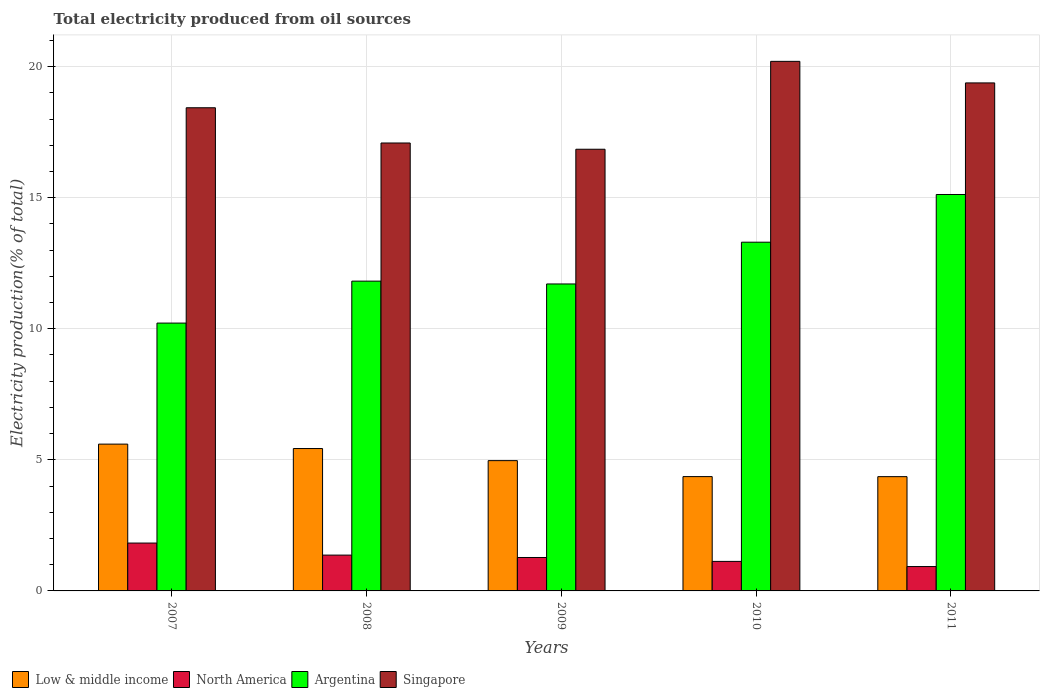How many groups of bars are there?
Make the answer very short. 5. Are the number of bars per tick equal to the number of legend labels?
Keep it short and to the point. Yes. How many bars are there on the 3rd tick from the left?
Give a very brief answer. 4. How many bars are there on the 5th tick from the right?
Give a very brief answer. 4. What is the label of the 1st group of bars from the left?
Give a very brief answer. 2007. In how many cases, is the number of bars for a given year not equal to the number of legend labels?
Your answer should be very brief. 0. What is the total electricity produced in North America in 2007?
Give a very brief answer. 1.83. Across all years, what is the maximum total electricity produced in Singapore?
Your answer should be compact. 20.2. Across all years, what is the minimum total electricity produced in Low & middle income?
Offer a very short reply. 4.36. In which year was the total electricity produced in Argentina maximum?
Offer a very short reply. 2011. What is the total total electricity produced in Argentina in the graph?
Provide a succinct answer. 62.17. What is the difference between the total electricity produced in North America in 2010 and that in 2011?
Ensure brevity in your answer.  0.2. What is the difference between the total electricity produced in North America in 2008 and the total electricity produced in Singapore in 2011?
Your answer should be very brief. -18.01. What is the average total electricity produced in North America per year?
Your response must be concise. 1.3. In the year 2007, what is the difference between the total electricity produced in Argentina and total electricity produced in Singapore?
Ensure brevity in your answer.  -8.21. What is the ratio of the total electricity produced in North America in 2007 to that in 2008?
Your response must be concise. 1.34. Is the total electricity produced in Low & middle income in 2008 less than that in 2011?
Make the answer very short. No. What is the difference between the highest and the second highest total electricity produced in Singapore?
Offer a terse response. 0.82. What is the difference between the highest and the lowest total electricity produced in Singapore?
Give a very brief answer. 3.35. In how many years, is the total electricity produced in Low & middle income greater than the average total electricity produced in Low & middle income taken over all years?
Your answer should be compact. 3. Is the sum of the total electricity produced in Argentina in 2007 and 2010 greater than the maximum total electricity produced in Low & middle income across all years?
Make the answer very short. Yes. What does the 4th bar from the left in 2011 represents?
Your answer should be compact. Singapore. Are the values on the major ticks of Y-axis written in scientific E-notation?
Offer a very short reply. No. Does the graph contain any zero values?
Your answer should be very brief. No. Does the graph contain grids?
Make the answer very short. Yes. Where does the legend appear in the graph?
Offer a terse response. Bottom left. How are the legend labels stacked?
Your answer should be very brief. Horizontal. What is the title of the graph?
Provide a short and direct response. Total electricity produced from oil sources. Does "Guyana" appear as one of the legend labels in the graph?
Provide a succinct answer. No. What is the label or title of the Y-axis?
Ensure brevity in your answer.  Electricity production(% of total). What is the Electricity production(% of total) of Low & middle income in 2007?
Make the answer very short. 5.6. What is the Electricity production(% of total) of North America in 2007?
Your response must be concise. 1.83. What is the Electricity production(% of total) in Argentina in 2007?
Your answer should be compact. 10.22. What is the Electricity production(% of total) in Singapore in 2007?
Provide a succinct answer. 18.43. What is the Electricity production(% of total) in Low & middle income in 2008?
Offer a terse response. 5.43. What is the Electricity production(% of total) of North America in 2008?
Provide a succinct answer. 1.37. What is the Electricity production(% of total) of Argentina in 2008?
Your answer should be compact. 11.82. What is the Electricity production(% of total) in Singapore in 2008?
Give a very brief answer. 17.09. What is the Electricity production(% of total) in Low & middle income in 2009?
Ensure brevity in your answer.  4.97. What is the Electricity production(% of total) in North America in 2009?
Give a very brief answer. 1.28. What is the Electricity production(% of total) of Argentina in 2009?
Make the answer very short. 11.71. What is the Electricity production(% of total) of Singapore in 2009?
Make the answer very short. 16.85. What is the Electricity production(% of total) in Low & middle income in 2010?
Your response must be concise. 4.36. What is the Electricity production(% of total) in North America in 2010?
Your answer should be very brief. 1.13. What is the Electricity production(% of total) in Argentina in 2010?
Keep it short and to the point. 13.3. What is the Electricity production(% of total) of Singapore in 2010?
Provide a succinct answer. 20.2. What is the Electricity production(% of total) in Low & middle income in 2011?
Ensure brevity in your answer.  4.36. What is the Electricity production(% of total) in North America in 2011?
Provide a succinct answer. 0.93. What is the Electricity production(% of total) of Argentina in 2011?
Give a very brief answer. 15.12. What is the Electricity production(% of total) in Singapore in 2011?
Your answer should be very brief. 19.38. Across all years, what is the maximum Electricity production(% of total) in Low & middle income?
Provide a short and direct response. 5.6. Across all years, what is the maximum Electricity production(% of total) of North America?
Keep it short and to the point. 1.83. Across all years, what is the maximum Electricity production(% of total) in Argentina?
Keep it short and to the point. 15.12. Across all years, what is the maximum Electricity production(% of total) of Singapore?
Your answer should be compact. 20.2. Across all years, what is the minimum Electricity production(% of total) of Low & middle income?
Your response must be concise. 4.36. Across all years, what is the minimum Electricity production(% of total) of North America?
Give a very brief answer. 0.93. Across all years, what is the minimum Electricity production(% of total) of Argentina?
Keep it short and to the point. 10.22. Across all years, what is the minimum Electricity production(% of total) in Singapore?
Offer a terse response. 16.85. What is the total Electricity production(% of total) in Low & middle income in the graph?
Offer a terse response. 24.72. What is the total Electricity production(% of total) of North America in the graph?
Offer a terse response. 6.52. What is the total Electricity production(% of total) in Argentina in the graph?
Provide a succinct answer. 62.17. What is the total Electricity production(% of total) of Singapore in the graph?
Your answer should be very brief. 91.94. What is the difference between the Electricity production(% of total) of Low & middle income in 2007 and that in 2008?
Your answer should be compact. 0.17. What is the difference between the Electricity production(% of total) of North America in 2007 and that in 2008?
Keep it short and to the point. 0.46. What is the difference between the Electricity production(% of total) of Argentina in 2007 and that in 2008?
Your answer should be very brief. -1.6. What is the difference between the Electricity production(% of total) of Singapore in 2007 and that in 2008?
Your answer should be very brief. 1.34. What is the difference between the Electricity production(% of total) of Low & middle income in 2007 and that in 2009?
Keep it short and to the point. 0.63. What is the difference between the Electricity production(% of total) in North America in 2007 and that in 2009?
Your answer should be compact. 0.55. What is the difference between the Electricity production(% of total) of Argentina in 2007 and that in 2009?
Make the answer very short. -1.49. What is the difference between the Electricity production(% of total) in Singapore in 2007 and that in 2009?
Your answer should be very brief. 1.58. What is the difference between the Electricity production(% of total) of Low & middle income in 2007 and that in 2010?
Ensure brevity in your answer.  1.24. What is the difference between the Electricity production(% of total) in North America in 2007 and that in 2010?
Offer a very short reply. 0.7. What is the difference between the Electricity production(% of total) in Argentina in 2007 and that in 2010?
Your answer should be compact. -3.09. What is the difference between the Electricity production(% of total) of Singapore in 2007 and that in 2010?
Offer a terse response. -1.77. What is the difference between the Electricity production(% of total) in Low & middle income in 2007 and that in 2011?
Make the answer very short. 1.24. What is the difference between the Electricity production(% of total) of North America in 2007 and that in 2011?
Provide a succinct answer. 0.9. What is the difference between the Electricity production(% of total) of Argentina in 2007 and that in 2011?
Make the answer very short. -4.9. What is the difference between the Electricity production(% of total) of Singapore in 2007 and that in 2011?
Give a very brief answer. -0.95. What is the difference between the Electricity production(% of total) of Low & middle income in 2008 and that in 2009?
Offer a terse response. 0.46. What is the difference between the Electricity production(% of total) in North America in 2008 and that in 2009?
Your response must be concise. 0.09. What is the difference between the Electricity production(% of total) in Argentina in 2008 and that in 2009?
Your answer should be very brief. 0.11. What is the difference between the Electricity production(% of total) of Singapore in 2008 and that in 2009?
Your answer should be compact. 0.24. What is the difference between the Electricity production(% of total) in Low & middle income in 2008 and that in 2010?
Offer a very short reply. 1.07. What is the difference between the Electricity production(% of total) in North America in 2008 and that in 2010?
Make the answer very short. 0.24. What is the difference between the Electricity production(% of total) of Argentina in 2008 and that in 2010?
Your response must be concise. -1.49. What is the difference between the Electricity production(% of total) of Singapore in 2008 and that in 2010?
Offer a very short reply. -3.11. What is the difference between the Electricity production(% of total) in Low & middle income in 2008 and that in 2011?
Ensure brevity in your answer.  1.07. What is the difference between the Electricity production(% of total) in North America in 2008 and that in 2011?
Provide a succinct answer. 0.44. What is the difference between the Electricity production(% of total) of Argentina in 2008 and that in 2011?
Your response must be concise. -3.3. What is the difference between the Electricity production(% of total) of Singapore in 2008 and that in 2011?
Keep it short and to the point. -2.29. What is the difference between the Electricity production(% of total) of Low & middle income in 2009 and that in 2010?
Make the answer very short. 0.61. What is the difference between the Electricity production(% of total) in North America in 2009 and that in 2010?
Give a very brief answer. 0.15. What is the difference between the Electricity production(% of total) of Argentina in 2009 and that in 2010?
Your response must be concise. -1.59. What is the difference between the Electricity production(% of total) in Singapore in 2009 and that in 2010?
Your response must be concise. -3.35. What is the difference between the Electricity production(% of total) in Low & middle income in 2009 and that in 2011?
Make the answer very short. 0.61. What is the difference between the Electricity production(% of total) in North America in 2009 and that in 2011?
Give a very brief answer. 0.35. What is the difference between the Electricity production(% of total) in Argentina in 2009 and that in 2011?
Your answer should be very brief. -3.41. What is the difference between the Electricity production(% of total) in Singapore in 2009 and that in 2011?
Provide a short and direct response. -2.53. What is the difference between the Electricity production(% of total) in Low & middle income in 2010 and that in 2011?
Your response must be concise. 0. What is the difference between the Electricity production(% of total) of North America in 2010 and that in 2011?
Offer a terse response. 0.2. What is the difference between the Electricity production(% of total) in Argentina in 2010 and that in 2011?
Ensure brevity in your answer.  -1.82. What is the difference between the Electricity production(% of total) in Singapore in 2010 and that in 2011?
Give a very brief answer. 0.82. What is the difference between the Electricity production(% of total) of Low & middle income in 2007 and the Electricity production(% of total) of North America in 2008?
Your answer should be compact. 4.23. What is the difference between the Electricity production(% of total) in Low & middle income in 2007 and the Electricity production(% of total) in Argentina in 2008?
Provide a succinct answer. -6.22. What is the difference between the Electricity production(% of total) of Low & middle income in 2007 and the Electricity production(% of total) of Singapore in 2008?
Provide a short and direct response. -11.49. What is the difference between the Electricity production(% of total) of North America in 2007 and the Electricity production(% of total) of Argentina in 2008?
Your answer should be very brief. -9.99. What is the difference between the Electricity production(% of total) of North America in 2007 and the Electricity production(% of total) of Singapore in 2008?
Give a very brief answer. -15.26. What is the difference between the Electricity production(% of total) of Argentina in 2007 and the Electricity production(% of total) of Singapore in 2008?
Your response must be concise. -6.87. What is the difference between the Electricity production(% of total) of Low & middle income in 2007 and the Electricity production(% of total) of North America in 2009?
Keep it short and to the point. 4.32. What is the difference between the Electricity production(% of total) of Low & middle income in 2007 and the Electricity production(% of total) of Argentina in 2009?
Ensure brevity in your answer.  -6.11. What is the difference between the Electricity production(% of total) in Low & middle income in 2007 and the Electricity production(% of total) in Singapore in 2009?
Offer a very short reply. -11.25. What is the difference between the Electricity production(% of total) of North America in 2007 and the Electricity production(% of total) of Argentina in 2009?
Ensure brevity in your answer.  -9.88. What is the difference between the Electricity production(% of total) of North America in 2007 and the Electricity production(% of total) of Singapore in 2009?
Your answer should be very brief. -15.02. What is the difference between the Electricity production(% of total) of Argentina in 2007 and the Electricity production(% of total) of Singapore in 2009?
Keep it short and to the point. -6.63. What is the difference between the Electricity production(% of total) in Low & middle income in 2007 and the Electricity production(% of total) in North America in 2010?
Give a very brief answer. 4.47. What is the difference between the Electricity production(% of total) in Low & middle income in 2007 and the Electricity production(% of total) in Argentina in 2010?
Keep it short and to the point. -7.7. What is the difference between the Electricity production(% of total) in Low & middle income in 2007 and the Electricity production(% of total) in Singapore in 2010?
Provide a succinct answer. -14.6. What is the difference between the Electricity production(% of total) of North America in 2007 and the Electricity production(% of total) of Argentina in 2010?
Offer a terse response. -11.48. What is the difference between the Electricity production(% of total) in North America in 2007 and the Electricity production(% of total) in Singapore in 2010?
Offer a terse response. -18.37. What is the difference between the Electricity production(% of total) in Argentina in 2007 and the Electricity production(% of total) in Singapore in 2010?
Make the answer very short. -9.98. What is the difference between the Electricity production(% of total) in Low & middle income in 2007 and the Electricity production(% of total) in North America in 2011?
Your response must be concise. 4.67. What is the difference between the Electricity production(% of total) of Low & middle income in 2007 and the Electricity production(% of total) of Argentina in 2011?
Offer a terse response. -9.52. What is the difference between the Electricity production(% of total) of Low & middle income in 2007 and the Electricity production(% of total) of Singapore in 2011?
Make the answer very short. -13.78. What is the difference between the Electricity production(% of total) of North America in 2007 and the Electricity production(% of total) of Argentina in 2011?
Provide a short and direct response. -13.3. What is the difference between the Electricity production(% of total) in North America in 2007 and the Electricity production(% of total) in Singapore in 2011?
Make the answer very short. -17.55. What is the difference between the Electricity production(% of total) in Argentina in 2007 and the Electricity production(% of total) in Singapore in 2011?
Offer a terse response. -9.16. What is the difference between the Electricity production(% of total) of Low & middle income in 2008 and the Electricity production(% of total) of North America in 2009?
Make the answer very short. 4.16. What is the difference between the Electricity production(% of total) of Low & middle income in 2008 and the Electricity production(% of total) of Argentina in 2009?
Make the answer very short. -6.28. What is the difference between the Electricity production(% of total) in Low & middle income in 2008 and the Electricity production(% of total) in Singapore in 2009?
Offer a very short reply. -11.42. What is the difference between the Electricity production(% of total) of North America in 2008 and the Electricity production(% of total) of Argentina in 2009?
Provide a succinct answer. -10.34. What is the difference between the Electricity production(% of total) of North America in 2008 and the Electricity production(% of total) of Singapore in 2009?
Provide a short and direct response. -15.48. What is the difference between the Electricity production(% of total) of Argentina in 2008 and the Electricity production(% of total) of Singapore in 2009?
Offer a very short reply. -5.03. What is the difference between the Electricity production(% of total) of Low & middle income in 2008 and the Electricity production(% of total) of North America in 2010?
Provide a succinct answer. 4.3. What is the difference between the Electricity production(% of total) of Low & middle income in 2008 and the Electricity production(% of total) of Argentina in 2010?
Ensure brevity in your answer.  -7.87. What is the difference between the Electricity production(% of total) of Low & middle income in 2008 and the Electricity production(% of total) of Singapore in 2010?
Your answer should be very brief. -14.77. What is the difference between the Electricity production(% of total) in North America in 2008 and the Electricity production(% of total) in Argentina in 2010?
Provide a succinct answer. -11.94. What is the difference between the Electricity production(% of total) of North America in 2008 and the Electricity production(% of total) of Singapore in 2010?
Offer a very short reply. -18.83. What is the difference between the Electricity production(% of total) of Argentina in 2008 and the Electricity production(% of total) of Singapore in 2010?
Provide a short and direct response. -8.38. What is the difference between the Electricity production(% of total) of Low & middle income in 2008 and the Electricity production(% of total) of North America in 2011?
Keep it short and to the point. 4.5. What is the difference between the Electricity production(% of total) in Low & middle income in 2008 and the Electricity production(% of total) in Argentina in 2011?
Offer a terse response. -9.69. What is the difference between the Electricity production(% of total) in Low & middle income in 2008 and the Electricity production(% of total) in Singapore in 2011?
Your answer should be compact. -13.95. What is the difference between the Electricity production(% of total) of North America in 2008 and the Electricity production(% of total) of Argentina in 2011?
Your answer should be compact. -13.76. What is the difference between the Electricity production(% of total) in North America in 2008 and the Electricity production(% of total) in Singapore in 2011?
Make the answer very short. -18.01. What is the difference between the Electricity production(% of total) of Argentina in 2008 and the Electricity production(% of total) of Singapore in 2011?
Offer a terse response. -7.56. What is the difference between the Electricity production(% of total) of Low & middle income in 2009 and the Electricity production(% of total) of North America in 2010?
Keep it short and to the point. 3.84. What is the difference between the Electricity production(% of total) in Low & middle income in 2009 and the Electricity production(% of total) in Argentina in 2010?
Offer a terse response. -8.33. What is the difference between the Electricity production(% of total) of Low & middle income in 2009 and the Electricity production(% of total) of Singapore in 2010?
Your answer should be very brief. -15.23. What is the difference between the Electricity production(% of total) in North America in 2009 and the Electricity production(% of total) in Argentina in 2010?
Give a very brief answer. -12.03. What is the difference between the Electricity production(% of total) in North America in 2009 and the Electricity production(% of total) in Singapore in 2010?
Keep it short and to the point. -18.93. What is the difference between the Electricity production(% of total) in Argentina in 2009 and the Electricity production(% of total) in Singapore in 2010?
Keep it short and to the point. -8.49. What is the difference between the Electricity production(% of total) of Low & middle income in 2009 and the Electricity production(% of total) of North America in 2011?
Your response must be concise. 4.04. What is the difference between the Electricity production(% of total) of Low & middle income in 2009 and the Electricity production(% of total) of Argentina in 2011?
Ensure brevity in your answer.  -10.15. What is the difference between the Electricity production(% of total) in Low & middle income in 2009 and the Electricity production(% of total) in Singapore in 2011?
Ensure brevity in your answer.  -14.41. What is the difference between the Electricity production(% of total) in North America in 2009 and the Electricity production(% of total) in Argentina in 2011?
Provide a succinct answer. -13.85. What is the difference between the Electricity production(% of total) in North America in 2009 and the Electricity production(% of total) in Singapore in 2011?
Make the answer very short. -18.1. What is the difference between the Electricity production(% of total) of Argentina in 2009 and the Electricity production(% of total) of Singapore in 2011?
Make the answer very short. -7.67. What is the difference between the Electricity production(% of total) in Low & middle income in 2010 and the Electricity production(% of total) in North America in 2011?
Your response must be concise. 3.43. What is the difference between the Electricity production(% of total) of Low & middle income in 2010 and the Electricity production(% of total) of Argentina in 2011?
Provide a succinct answer. -10.76. What is the difference between the Electricity production(% of total) of Low & middle income in 2010 and the Electricity production(% of total) of Singapore in 2011?
Offer a very short reply. -15.02. What is the difference between the Electricity production(% of total) in North America in 2010 and the Electricity production(% of total) in Argentina in 2011?
Offer a very short reply. -14. What is the difference between the Electricity production(% of total) of North America in 2010 and the Electricity production(% of total) of Singapore in 2011?
Give a very brief answer. -18.25. What is the difference between the Electricity production(% of total) of Argentina in 2010 and the Electricity production(% of total) of Singapore in 2011?
Offer a terse response. -6.08. What is the average Electricity production(% of total) in Low & middle income per year?
Offer a very short reply. 4.94. What is the average Electricity production(% of total) of North America per year?
Give a very brief answer. 1.3. What is the average Electricity production(% of total) of Argentina per year?
Your answer should be very brief. 12.43. What is the average Electricity production(% of total) in Singapore per year?
Make the answer very short. 18.39. In the year 2007, what is the difference between the Electricity production(% of total) in Low & middle income and Electricity production(% of total) in North America?
Provide a short and direct response. 3.77. In the year 2007, what is the difference between the Electricity production(% of total) in Low & middle income and Electricity production(% of total) in Argentina?
Keep it short and to the point. -4.62. In the year 2007, what is the difference between the Electricity production(% of total) of Low & middle income and Electricity production(% of total) of Singapore?
Your response must be concise. -12.83. In the year 2007, what is the difference between the Electricity production(% of total) of North America and Electricity production(% of total) of Argentina?
Offer a very short reply. -8.39. In the year 2007, what is the difference between the Electricity production(% of total) in North America and Electricity production(% of total) in Singapore?
Give a very brief answer. -16.6. In the year 2007, what is the difference between the Electricity production(% of total) of Argentina and Electricity production(% of total) of Singapore?
Provide a short and direct response. -8.21. In the year 2008, what is the difference between the Electricity production(% of total) in Low & middle income and Electricity production(% of total) in North America?
Offer a terse response. 4.06. In the year 2008, what is the difference between the Electricity production(% of total) of Low & middle income and Electricity production(% of total) of Argentina?
Give a very brief answer. -6.39. In the year 2008, what is the difference between the Electricity production(% of total) in Low & middle income and Electricity production(% of total) in Singapore?
Your answer should be compact. -11.66. In the year 2008, what is the difference between the Electricity production(% of total) in North America and Electricity production(% of total) in Argentina?
Your answer should be very brief. -10.45. In the year 2008, what is the difference between the Electricity production(% of total) of North America and Electricity production(% of total) of Singapore?
Your answer should be compact. -15.72. In the year 2008, what is the difference between the Electricity production(% of total) of Argentina and Electricity production(% of total) of Singapore?
Offer a very short reply. -5.27. In the year 2009, what is the difference between the Electricity production(% of total) of Low & middle income and Electricity production(% of total) of North America?
Your answer should be very brief. 3.69. In the year 2009, what is the difference between the Electricity production(% of total) in Low & middle income and Electricity production(% of total) in Argentina?
Make the answer very short. -6.74. In the year 2009, what is the difference between the Electricity production(% of total) in Low & middle income and Electricity production(% of total) in Singapore?
Your answer should be compact. -11.88. In the year 2009, what is the difference between the Electricity production(% of total) of North America and Electricity production(% of total) of Argentina?
Your answer should be very brief. -10.43. In the year 2009, what is the difference between the Electricity production(% of total) in North America and Electricity production(% of total) in Singapore?
Provide a short and direct response. -15.57. In the year 2009, what is the difference between the Electricity production(% of total) of Argentina and Electricity production(% of total) of Singapore?
Provide a short and direct response. -5.14. In the year 2010, what is the difference between the Electricity production(% of total) in Low & middle income and Electricity production(% of total) in North America?
Your answer should be very brief. 3.23. In the year 2010, what is the difference between the Electricity production(% of total) of Low & middle income and Electricity production(% of total) of Argentina?
Provide a succinct answer. -8.94. In the year 2010, what is the difference between the Electricity production(% of total) of Low & middle income and Electricity production(% of total) of Singapore?
Provide a short and direct response. -15.84. In the year 2010, what is the difference between the Electricity production(% of total) of North America and Electricity production(% of total) of Argentina?
Offer a terse response. -12.18. In the year 2010, what is the difference between the Electricity production(% of total) of North America and Electricity production(% of total) of Singapore?
Your response must be concise. -19.07. In the year 2010, what is the difference between the Electricity production(% of total) in Argentina and Electricity production(% of total) in Singapore?
Your answer should be compact. -6.9. In the year 2011, what is the difference between the Electricity production(% of total) in Low & middle income and Electricity production(% of total) in North America?
Keep it short and to the point. 3.43. In the year 2011, what is the difference between the Electricity production(% of total) of Low & middle income and Electricity production(% of total) of Argentina?
Offer a terse response. -10.76. In the year 2011, what is the difference between the Electricity production(% of total) in Low & middle income and Electricity production(% of total) in Singapore?
Ensure brevity in your answer.  -15.02. In the year 2011, what is the difference between the Electricity production(% of total) in North America and Electricity production(% of total) in Argentina?
Keep it short and to the point. -14.19. In the year 2011, what is the difference between the Electricity production(% of total) in North America and Electricity production(% of total) in Singapore?
Your answer should be compact. -18.45. In the year 2011, what is the difference between the Electricity production(% of total) of Argentina and Electricity production(% of total) of Singapore?
Provide a succinct answer. -4.26. What is the ratio of the Electricity production(% of total) in Low & middle income in 2007 to that in 2008?
Provide a short and direct response. 1.03. What is the ratio of the Electricity production(% of total) of North America in 2007 to that in 2008?
Make the answer very short. 1.34. What is the ratio of the Electricity production(% of total) in Argentina in 2007 to that in 2008?
Provide a succinct answer. 0.86. What is the ratio of the Electricity production(% of total) in Singapore in 2007 to that in 2008?
Offer a very short reply. 1.08. What is the ratio of the Electricity production(% of total) of Low & middle income in 2007 to that in 2009?
Give a very brief answer. 1.13. What is the ratio of the Electricity production(% of total) of North America in 2007 to that in 2009?
Provide a short and direct response. 1.43. What is the ratio of the Electricity production(% of total) of Argentina in 2007 to that in 2009?
Keep it short and to the point. 0.87. What is the ratio of the Electricity production(% of total) of Singapore in 2007 to that in 2009?
Offer a very short reply. 1.09. What is the ratio of the Electricity production(% of total) of Low & middle income in 2007 to that in 2010?
Offer a terse response. 1.28. What is the ratio of the Electricity production(% of total) of North America in 2007 to that in 2010?
Keep it short and to the point. 1.62. What is the ratio of the Electricity production(% of total) in Argentina in 2007 to that in 2010?
Offer a terse response. 0.77. What is the ratio of the Electricity production(% of total) of Singapore in 2007 to that in 2010?
Your response must be concise. 0.91. What is the ratio of the Electricity production(% of total) of Low & middle income in 2007 to that in 2011?
Ensure brevity in your answer.  1.28. What is the ratio of the Electricity production(% of total) in North America in 2007 to that in 2011?
Offer a terse response. 1.96. What is the ratio of the Electricity production(% of total) in Argentina in 2007 to that in 2011?
Offer a very short reply. 0.68. What is the ratio of the Electricity production(% of total) of Singapore in 2007 to that in 2011?
Keep it short and to the point. 0.95. What is the ratio of the Electricity production(% of total) in Low & middle income in 2008 to that in 2009?
Your answer should be compact. 1.09. What is the ratio of the Electricity production(% of total) of North America in 2008 to that in 2009?
Give a very brief answer. 1.07. What is the ratio of the Electricity production(% of total) in Argentina in 2008 to that in 2009?
Offer a terse response. 1.01. What is the ratio of the Electricity production(% of total) of Singapore in 2008 to that in 2009?
Keep it short and to the point. 1.01. What is the ratio of the Electricity production(% of total) in Low & middle income in 2008 to that in 2010?
Offer a very short reply. 1.25. What is the ratio of the Electricity production(% of total) in North America in 2008 to that in 2010?
Ensure brevity in your answer.  1.21. What is the ratio of the Electricity production(% of total) in Argentina in 2008 to that in 2010?
Your response must be concise. 0.89. What is the ratio of the Electricity production(% of total) of Singapore in 2008 to that in 2010?
Offer a terse response. 0.85. What is the ratio of the Electricity production(% of total) in Low & middle income in 2008 to that in 2011?
Offer a very short reply. 1.25. What is the ratio of the Electricity production(% of total) in North America in 2008 to that in 2011?
Offer a very short reply. 1.47. What is the ratio of the Electricity production(% of total) in Argentina in 2008 to that in 2011?
Your response must be concise. 0.78. What is the ratio of the Electricity production(% of total) of Singapore in 2008 to that in 2011?
Your response must be concise. 0.88. What is the ratio of the Electricity production(% of total) in Low & middle income in 2009 to that in 2010?
Your response must be concise. 1.14. What is the ratio of the Electricity production(% of total) in North America in 2009 to that in 2010?
Offer a terse response. 1.13. What is the ratio of the Electricity production(% of total) in Argentina in 2009 to that in 2010?
Ensure brevity in your answer.  0.88. What is the ratio of the Electricity production(% of total) in Singapore in 2009 to that in 2010?
Make the answer very short. 0.83. What is the ratio of the Electricity production(% of total) in Low & middle income in 2009 to that in 2011?
Offer a very short reply. 1.14. What is the ratio of the Electricity production(% of total) in North America in 2009 to that in 2011?
Provide a succinct answer. 1.37. What is the ratio of the Electricity production(% of total) of Argentina in 2009 to that in 2011?
Your answer should be compact. 0.77. What is the ratio of the Electricity production(% of total) in Singapore in 2009 to that in 2011?
Offer a very short reply. 0.87. What is the ratio of the Electricity production(% of total) of North America in 2010 to that in 2011?
Make the answer very short. 1.21. What is the ratio of the Electricity production(% of total) in Argentina in 2010 to that in 2011?
Offer a very short reply. 0.88. What is the ratio of the Electricity production(% of total) in Singapore in 2010 to that in 2011?
Ensure brevity in your answer.  1.04. What is the difference between the highest and the second highest Electricity production(% of total) in Low & middle income?
Your response must be concise. 0.17. What is the difference between the highest and the second highest Electricity production(% of total) of North America?
Keep it short and to the point. 0.46. What is the difference between the highest and the second highest Electricity production(% of total) of Argentina?
Provide a succinct answer. 1.82. What is the difference between the highest and the second highest Electricity production(% of total) of Singapore?
Keep it short and to the point. 0.82. What is the difference between the highest and the lowest Electricity production(% of total) in Low & middle income?
Keep it short and to the point. 1.24. What is the difference between the highest and the lowest Electricity production(% of total) of North America?
Provide a short and direct response. 0.9. What is the difference between the highest and the lowest Electricity production(% of total) in Argentina?
Offer a very short reply. 4.9. What is the difference between the highest and the lowest Electricity production(% of total) of Singapore?
Provide a short and direct response. 3.35. 